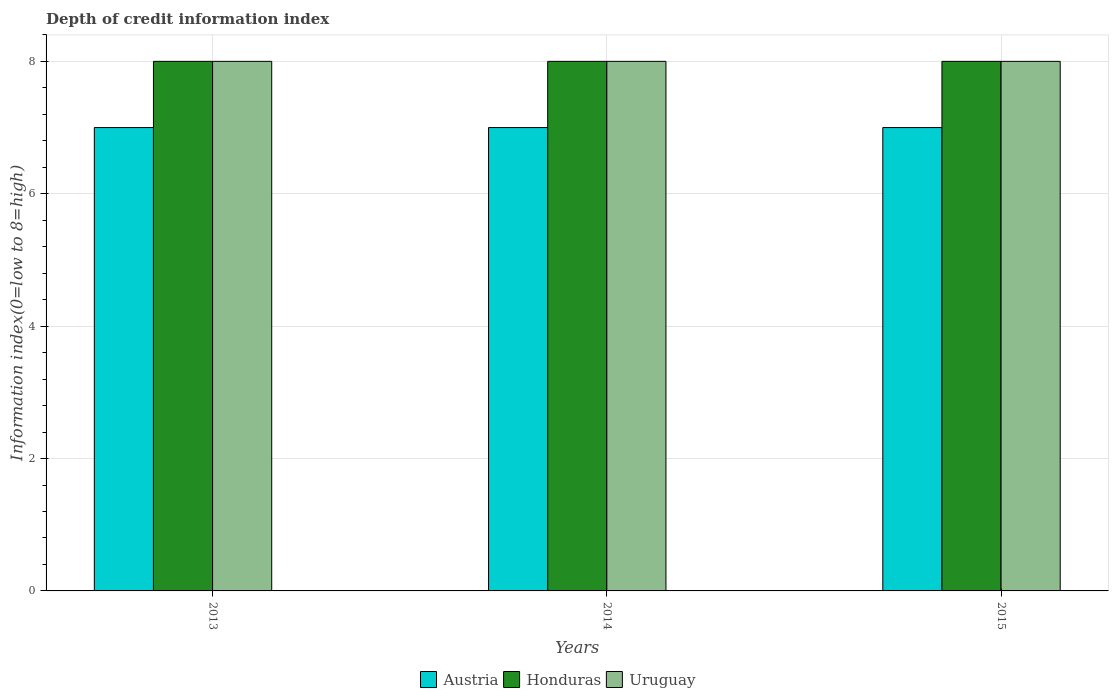How many bars are there on the 3rd tick from the left?
Offer a terse response. 3. How many bars are there on the 2nd tick from the right?
Give a very brief answer. 3. What is the label of the 3rd group of bars from the left?
Ensure brevity in your answer.  2015. What is the information index in Uruguay in 2013?
Your answer should be compact. 8. Across all years, what is the maximum information index in Uruguay?
Your answer should be very brief. 8. Across all years, what is the minimum information index in Uruguay?
Give a very brief answer. 8. In which year was the information index in Uruguay maximum?
Your answer should be very brief. 2013. In which year was the information index in Honduras minimum?
Your answer should be compact. 2013. What is the total information index in Honduras in the graph?
Offer a very short reply. 24. What is the difference between the information index in Austria in 2015 and the information index in Honduras in 2013?
Your answer should be compact. -1. In the year 2015, what is the difference between the information index in Uruguay and information index in Honduras?
Offer a terse response. 0. In how many years, is the information index in Uruguay greater than 4.4?
Your response must be concise. 3. Is the information index in Honduras in 2014 less than that in 2015?
Your answer should be very brief. No. Is the difference between the information index in Uruguay in 2013 and 2014 greater than the difference between the information index in Honduras in 2013 and 2014?
Offer a very short reply. No. What is the difference between the highest and the second highest information index in Uruguay?
Your response must be concise. 0. What is the difference between the highest and the lowest information index in Austria?
Offer a terse response. 0. What does the 3rd bar from the left in 2014 represents?
Keep it short and to the point. Uruguay. What does the 2nd bar from the right in 2014 represents?
Provide a short and direct response. Honduras. Does the graph contain any zero values?
Provide a short and direct response. No. Where does the legend appear in the graph?
Keep it short and to the point. Bottom center. How many legend labels are there?
Provide a succinct answer. 3. How are the legend labels stacked?
Give a very brief answer. Horizontal. What is the title of the graph?
Make the answer very short. Depth of credit information index. Does "Latvia" appear as one of the legend labels in the graph?
Your answer should be compact. No. What is the label or title of the X-axis?
Give a very brief answer. Years. What is the label or title of the Y-axis?
Keep it short and to the point. Information index(0=low to 8=high). What is the Information index(0=low to 8=high) of Austria in 2013?
Offer a terse response. 7. What is the Information index(0=low to 8=high) in Honduras in 2013?
Provide a short and direct response. 8. What is the Information index(0=low to 8=high) of Uruguay in 2014?
Keep it short and to the point. 8. What is the Information index(0=low to 8=high) of Austria in 2015?
Provide a succinct answer. 7. Across all years, what is the minimum Information index(0=low to 8=high) in Honduras?
Your response must be concise. 8. What is the difference between the Information index(0=low to 8=high) in Austria in 2013 and that in 2014?
Provide a succinct answer. 0. What is the difference between the Information index(0=low to 8=high) of Honduras in 2013 and that in 2014?
Offer a terse response. 0. What is the difference between the Information index(0=low to 8=high) of Austria in 2013 and that in 2015?
Provide a succinct answer. 0. What is the difference between the Information index(0=low to 8=high) of Honduras in 2013 and that in 2015?
Offer a very short reply. 0. What is the difference between the Information index(0=low to 8=high) of Uruguay in 2014 and that in 2015?
Your answer should be compact. 0. What is the difference between the Information index(0=low to 8=high) of Austria in 2013 and the Information index(0=low to 8=high) of Uruguay in 2014?
Your answer should be compact. -1. What is the difference between the Information index(0=low to 8=high) in Austria in 2013 and the Information index(0=low to 8=high) in Honduras in 2015?
Offer a very short reply. -1. What is the difference between the Information index(0=low to 8=high) of Austria in 2013 and the Information index(0=low to 8=high) of Uruguay in 2015?
Offer a very short reply. -1. What is the difference between the Information index(0=low to 8=high) of Austria in 2014 and the Information index(0=low to 8=high) of Honduras in 2015?
Offer a very short reply. -1. In the year 2013, what is the difference between the Information index(0=low to 8=high) in Austria and Information index(0=low to 8=high) in Uruguay?
Give a very brief answer. -1. In the year 2015, what is the difference between the Information index(0=low to 8=high) in Austria and Information index(0=low to 8=high) in Uruguay?
Ensure brevity in your answer.  -1. In the year 2015, what is the difference between the Information index(0=low to 8=high) in Honduras and Information index(0=low to 8=high) in Uruguay?
Keep it short and to the point. 0. What is the ratio of the Information index(0=low to 8=high) of Austria in 2013 to that in 2015?
Your answer should be compact. 1. What is the ratio of the Information index(0=low to 8=high) of Honduras in 2013 to that in 2015?
Offer a very short reply. 1. What is the ratio of the Information index(0=low to 8=high) in Uruguay in 2013 to that in 2015?
Make the answer very short. 1. What is the difference between the highest and the second highest Information index(0=low to 8=high) of Uruguay?
Your response must be concise. 0. What is the difference between the highest and the lowest Information index(0=low to 8=high) of Austria?
Your response must be concise. 0. What is the difference between the highest and the lowest Information index(0=low to 8=high) in Honduras?
Provide a succinct answer. 0. 